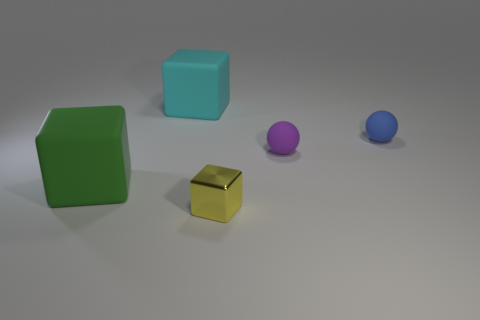Subtract all yellow metallic blocks. How many blocks are left? 2 Subtract 1 cubes. How many cubes are left? 2 Add 4 cyan objects. How many objects exist? 9 Subtract all cyan blocks. How many blocks are left? 2 Subtract all cyan cylinders. How many blue balls are left? 1 Add 3 shiny cubes. How many shiny cubes are left? 4 Add 4 big blocks. How many big blocks exist? 6 Subtract 0 brown spheres. How many objects are left? 5 Subtract all balls. How many objects are left? 3 Subtract all brown blocks. Subtract all gray spheres. How many blocks are left? 3 